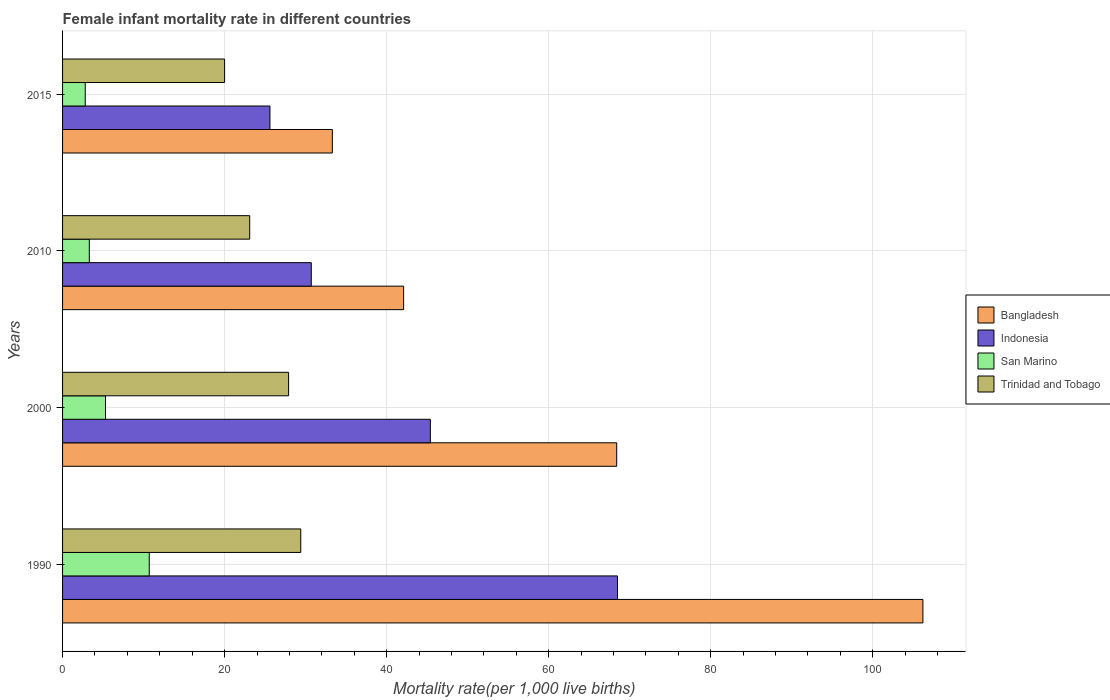How many different coloured bars are there?
Your answer should be very brief. 4. How many groups of bars are there?
Offer a very short reply. 4. Are the number of bars on each tick of the Y-axis equal?
Provide a short and direct response. Yes. In how many cases, is the number of bars for a given year not equal to the number of legend labels?
Keep it short and to the point. 0. Across all years, what is the maximum female infant mortality rate in Bangladesh?
Keep it short and to the point. 106.2. Across all years, what is the minimum female infant mortality rate in Trinidad and Tobago?
Offer a terse response. 20. In which year was the female infant mortality rate in San Marino minimum?
Make the answer very short. 2015. What is the total female infant mortality rate in Indonesia in the graph?
Offer a terse response. 170.2. What is the difference between the female infant mortality rate in Trinidad and Tobago in 2000 and that in 2010?
Your answer should be very brief. 4.8. What is the difference between the female infant mortality rate in San Marino in 2010 and the female infant mortality rate in Trinidad and Tobago in 2000?
Your answer should be compact. -24.6. What is the average female infant mortality rate in Indonesia per year?
Offer a terse response. 42.55. In the year 1990, what is the difference between the female infant mortality rate in Bangladesh and female infant mortality rate in San Marino?
Offer a terse response. 95.5. What is the ratio of the female infant mortality rate in Trinidad and Tobago in 2000 to that in 2010?
Your response must be concise. 1.21. Is the female infant mortality rate in San Marino in 2000 less than that in 2015?
Offer a terse response. No. Is the difference between the female infant mortality rate in Bangladesh in 2000 and 2015 greater than the difference between the female infant mortality rate in San Marino in 2000 and 2015?
Give a very brief answer. Yes. What is the difference between the highest and the second highest female infant mortality rate in Trinidad and Tobago?
Provide a short and direct response. 1.5. What is the difference between the highest and the lowest female infant mortality rate in Trinidad and Tobago?
Provide a succinct answer. 9.4. In how many years, is the female infant mortality rate in Indonesia greater than the average female infant mortality rate in Indonesia taken over all years?
Make the answer very short. 2. What does the 1st bar from the top in 1990 represents?
Give a very brief answer. Trinidad and Tobago. Is it the case that in every year, the sum of the female infant mortality rate in Bangladesh and female infant mortality rate in Indonesia is greater than the female infant mortality rate in San Marino?
Ensure brevity in your answer.  Yes. Are all the bars in the graph horizontal?
Your answer should be compact. Yes. How many years are there in the graph?
Your response must be concise. 4. What is the difference between two consecutive major ticks on the X-axis?
Make the answer very short. 20. Are the values on the major ticks of X-axis written in scientific E-notation?
Ensure brevity in your answer.  No. Does the graph contain grids?
Offer a terse response. Yes. How many legend labels are there?
Your response must be concise. 4. What is the title of the graph?
Ensure brevity in your answer.  Female infant mortality rate in different countries. What is the label or title of the X-axis?
Provide a short and direct response. Mortality rate(per 1,0 live births). What is the label or title of the Y-axis?
Give a very brief answer. Years. What is the Mortality rate(per 1,000 live births) of Bangladesh in 1990?
Offer a terse response. 106.2. What is the Mortality rate(per 1,000 live births) in Indonesia in 1990?
Offer a terse response. 68.5. What is the Mortality rate(per 1,000 live births) of Trinidad and Tobago in 1990?
Make the answer very short. 29.4. What is the Mortality rate(per 1,000 live births) in Bangladesh in 2000?
Your response must be concise. 68.4. What is the Mortality rate(per 1,000 live births) of Indonesia in 2000?
Your response must be concise. 45.4. What is the Mortality rate(per 1,000 live births) in San Marino in 2000?
Provide a succinct answer. 5.3. What is the Mortality rate(per 1,000 live births) of Trinidad and Tobago in 2000?
Provide a succinct answer. 27.9. What is the Mortality rate(per 1,000 live births) of Bangladesh in 2010?
Offer a terse response. 42.1. What is the Mortality rate(per 1,000 live births) of Indonesia in 2010?
Provide a short and direct response. 30.7. What is the Mortality rate(per 1,000 live births) in Trinidad and Tobago in 2010?
Your response must be concise. 23.1. What is the Mortality rate(per 1,000 live births) in Bangladesh in 2015?
Offer a very short reply. 33.3. What is the Mortality rate(per 1,000 live births) of Indonesia in 2015?
Keep it short and to the point. 25.6. Across all years, what is the maximum Mortality rate(per 1,000 live births) of Bangladesh?
Give a very brief answer. 106.2. Across all years, what is the maximum Mortality rate(per 1,000 live births) in Indonesia?
Your answer should be very brief. 68.5. Across all years, what is the maximum Mortality rate(per 1,000 live births) of Trinidad and Tobago?
Keep it short and to the point. 29.4. Across all years, what is the minimum Mortality rate(per 1,000 live births) in Bangladesh?
Your answer should be very brief. 33.3. Across all years, what is the minimum Mortality rate(per 1,000 live births) of Indonesia?
Give a very brief answer. 25.6. What is the total Mortality rate(per 1,000 live births) in Bangladesh in the graph?
Your answer should be compact. 250. What is the total Mortality rate(per 1,000 live births) in Indonesia in the graph?
Your response must be concise. 170.2. What is the total Mortality rate(per 1,000 live births) of San Marino in the graph?
Provide a succinct answer. 22.1. What is the total Mortality rate(per 1,000 live births) in Trinidad and Tobago in the graph?
Provide a short and direct response. 100.4. What is the difference between the Mortality rate(per 1,000 live births) of Bangladesh in 1990 and that in 2000?
Provide a succinct answer. 37.8. What is the difference between the Mortality rate(per 1,000 live births) of Indonesia in 1990 and that in 2000?
Offer a very short reply. 23.1. What is the difference between the Mortality rate(per 1,000 live births) in San Marino in 1990 and that in 2000?
Offer a terse response. 5.4. What is the difference between the Mortality rate(per 1,000 live births) in Trinidad and Tobago in 1990 and that in 2000?
Provide a short and direct response. 1.5. What is the difference between the Mortality rate(per 1,000 live births) of Bangladesh in 1990 and that in 2010?
Offer a very short reply. 64.1. What is the difference between the Mortality rate(per 1,000 live births) of Indonesia in 1990 and that in 2010?
Offer a very short reply. 37.8. What is the difference between the Mortality rate(per 1,000 live births) of Bangladesh in 1990 and that in 2015?
Your answer should be compact. 72.9. What is the difference between the Mortality rate(per 1,000 live births) in Indonesia in 1990 and that in 2015?
Offer a terse response. 42.9. What is the difference between the Mortality rate(per 1,000 live births) in Bangladesh in 2000 and that in 2010?
Offer a terse response. 26.3. What is the difference between the Mortality rate(per 1,000 live births) of Indonesia in 2000 and that in 2010?
Your answer should be compact. 14.7. What is the difference between the Mortality rate(per 1,000 live births) of San Marino in 2000 and that in 2010?
Offer a very short reply. 2. What is the difference between the Mortality rate(per 1,000 live births) of Bangladesh in 2000 and that in 2015?
Your answer should be very brief. 35.1. What is the difference between the Mortality rate(per 1,000 live births) in Indonesia in 2000 and that in 2015?
Provide a succinct answer. 19.8. What is the difference between the Mortality rate(per 1,000 live births) of Trinidad and Tobago in 2000 and that in 2015?
Ensure brevity in your answer.  7.9. What is the difference between the Mortality rate(per 1,000 live births) in Bangladesh in 2010 and that in 2015?
Give a very brief answer. 8.8. What is the difference between the Mortality rate(per 1,000 live births) in Indonesia in 2010 and that in 2015?
Give a very brief answer. 5.1. What is the difference between the Mortality rate(per 1,000 live births) of Bangladesh in 1990 and the Mortality rate(per 1,000 live births) of Indonesia in 2000?
Ensure brevity in your answer.  60.8. What is the difference between the Mortality rate(per 1,000 live births) of Bangladesh in 1990 and the Mortality rate(per 1,000 live births) of San Marino in 2000?
Ensure brevity in your answer.  100.9. What is the difference between the Mortality rate(per 1,000 live births) of Bangladesh in 1990 and the Mortality rate(per 1,000 live births) of Trinidad and Tobago in 2000?
Ensure brevity in your answer.  78.3. What is the difference between the Mortality rate(per 1,000 live births) of Indonesia in 1990 and the Mortality rate(per 1,000 live births) of San Marino in 2000?
Your answer should be very brief. 63.2. What is the difference between the Mortality rate(per 1,000 live births) in Indonesia in 1990 and the Mortality rate(per 1,000 live births) in Trinidad and Tobago in 2000?
Your answer should be very brief. 40.6. What is the difference between the Mortality rate(per 1,000 live births) in San Marino in 1990 and the Mortality rate(per 1,000 live births) in Trinidad and Tobago in 2000?
Make the answer very short. -17.2. What is the difference between the Mortality rate(per 1,000 live births) in Bangladesh in 1990 and the Mortality rate(per 1,000 live births) in Indonesia in 2010?
Provide a short and direct response. 75.5. What is the difference between the Mortality rate(per 1,000 live births) in Bangladesh in 1990 and the Mortality rate(per 1,000 live births) in San Marino in 2010?
Keep it short and to the point. 102.9. What is the difference between the Mortality rate(per 1,000 live births) of Bangladesh in 1990 and the Mortality rate(per 1,000 live births) of Trinidad and Tobago in 2010?
Make the answer very short. 83.1. What is the difference between the Mortality rate(per 1,000 live births) of Indonesia in 1990 and the Mortality rate(per 1,000 live births) of San Marino in 2010?
Ensure brevity in your answer.  65.2. What is the difference between the Mortality rate(per 1,000 live births) of Indonesia in 1990 and the Mortality rate(per 1,000 live births) of Trinidad and Tobago in 2010?
Ensure brevity in your answer.  45.4. What is the difference between the Mortality rate(per 1,000 live births) in Bangladesh in 1990 and the Mortality rate(per 1,000 live births) in Indonesia in 2015?
Offer a very short reply. 80.6. What is the difference between the Mortality rate(per 1,000 live births) of Bangladesh in 1990 and the Mortality rate(per 1,000 live births) of San Marino in 2015?
Your response must be concise. 103.4. What is the difference between the Mortality rate(per 1,000 live births) of Bangladesh in 1990 and the Mortality rate(per 1,000 live births) of Trinidad and Tobago in 2015?
Your answer should be very brief. 86.2. What is the difference between the Mortality rate(per 1,000 live births) of Indonesia in 1990 and the Mortality rate(per 1,000 live births) of San Marino in 2015?
Your answer should be very brief. 65.7. What is the difference between the Mortality rate(per 1,000 live births) in Indonesia in 1990 and the Mortality rate(per 1,000 live births) in Trinidad and Tobago in 2015?
Give a very brief answer. 48.5. What is the difference between the Mortality rate(per 1,000 live births) in Bangladesh in 2000 and the Mortality rate(per 1,000 live births) in Indonesia in 2010?
Your answer should be compact. 37.7. What is the difference between the Mortality rate(per 1,000 live births) in Bangladesh in 2000 and the Mortality rate(per 1,000 live births) in San Marino in 2010?
Keep it short and to the point. 65.1. What is the difference between the Mortality rate(per 1,000 live births) of Bangladesh in 2000 and the Mortality rate(per 1,000 live births) of Trinidad and Tobago in 2010?
Your response must be concise. 45.3. What is the difference between the Mortality rate(per 1,000 live births) in Indonesia in 2000 and the Mortality rate(per 1,000 live births) in San Marino in 2010?
Make the answer very short. 42.1. What is the difference between the Mortality rate(per 1,000 live births) in Indonesia in 2000 and the Mortality rate(per 1,000 live births) in Trinidad and Tobago in 2010?
Your answer should be compact. 22.3. What is the difference between the Mortality rate(per 1,000 live births) in San Marino in 2000 and the Mortality rate(per 1,000 live births) in Trinidad and Tobago in 2010?
Ensure brevity in your answer.  -17.8. What is the difference between the Mortality rate(per 1,000 live births) of Bangladesh in 2000 and the Mortality rate(per 1,000 live births) of Indonesia in 2015?
Provide a succinct answer. 42.8. What is the difference between the Mortality rate(per 1,000 live births) in Bangladesh in 2000 and the Mortality rate(per 1,000 live births) in San Marino in 2015?
Offer a very short reply. 65.6. What is the difference between the Mortality rate(per 1,000 live births) in Bangladesh in 2000 and the Mortality rate(per 1,000 live births) in Trinidad and Tobago in 2015?
Ensure brevity in your answer.  48.4. What is the difference between the Mortality rate(per 1,000 live births) in Indonesia in 2000 and the Mortality rate(per 1,000 live births) in San Marino in 2015?
Your response must be concise. 42.6. What is the difference between the Mortality rate(per 1,000 live births) in Indonesia in 2000 and the Mortality rate(per 1,000 live births) in Trinidad and Tobago in 2015?
Your response must be concise. 25.4. What is the difference between the Mortality rate(per 1,000 live births) in San Marino in 2000 and the Mortality rate(per 1,000 live births) in Trinidad and Tobago in 2015?
Your answer should be compact. -14.7. What is the difference between the Mortality rate(per 1,000 live births) in Bangladesh in 2010 and the Mortality rate(per 1,000 live births) in San Marino in 2015?
Offer a terse response. 39.3. What is the difference between the Mortality rate(per 1,000 live births) in Bangladesh in 2010 and the Mortality rate(per 1,000 live births) in Trinidad and Tobago in 2015?
Your answer should be compact. 22.1. What is the difference between the Mortality rate(per 1,000 live births) in Indonesia in 2010 and the Mortality rate(per 1,000 live births) in San Marino in 2015?
Your answer should be very brief. 27.9. What is the difference between the Mortality rate(per 1,000 live births) in San Marino in 2010 and the Mortality rate(per 1,000 live births) in Trinidad and Tobago in 2015?
Offer a very short reply. -16.7. What is the average Mortality rate(per 1,000 live births) in Bangladesh per year?
Ensure brevity in your answer.  62.5. What is the average Mortality rate(per 1,000 live births) in Indonesia per year?
Provide a short and direct response. 42.55. What is the average Mortality rate(per 1,000 live births) in San Marino per year?
Your response must be concise. 5.53. What is the average Mortality rate(per 1,000 live births) of Trinidad and Tobago per year?
Your response must be concise. 25.1. In the year 1990, what is the difference between the Mortality rate(per 1,000 live births) in Bangladesh and Mortality rate(per 1,000 live births) in Indonesia?
Provide a succinct answer. 37.7. In the year 1990, what is the difference between the Mortality rate(per 1,000 live births) in Bangladesh and Mortality rate(per 1,000 live births) in San Marino?
Make the answer very short. 95.5. In the year 1990, what is the difference between the Mortality rate(per 1,000 live births) in Bangladesh and Mortality rate(per 1,000 live births) in Trinidad and Tobago?
Give a very brief answer. 76.8. In the year 1990, what is the difference between the Mortality rate(per 1,000 live births) in Indonesia and Mortality rate(per 1,000 live births) in San Marino?
Ensure brevity in your answer.  57.8. In the year 1990, what is the difference between the Mortality rate(per 1,000 live births) of Indonesia and Mortality rate(per 1,000 live births) of Trinidad and Tobago?
Provide a succinct answer. 39.1. In the year 1990, what is the difference between the Mortality rate(per 1,000 live births) in San Marino and Mortality rate(per 1,000 live births) in Trinidad and Tobago?
Your response must be concise. -18.7. In the year 2000, what is the difference between the Mortality rate(per 1,000 live births) of Bangladesh and Mortality rate(per 1,000 live births) of San Marino?
Offer a terse response. 63.1. In the year 2000, what is the difference between the Mortality rate(per 1,000 live births) in Bangladesh and Mortality rate(per 1,000 live births) in Trinidad and Tobago?
Your answer should be very brief. 40.5. In the year 2000, what is the difference between the Mortality rate(per 1,000 live births) of Indonesia and Mortality rate(per 1,000 live births) of San Marino?
Offer a very short reply. 40.1. In the year 2000, what is the difference between the Mortality rate(per 1,000 live births) in San Marino and Mortality rate(per 1,000 live births) in Trinidad and Tobago?
Keep it short and to the point. -22.6. In the year 2010, what is the difference between the Mortality rate(per 1,000 live births) of Bangladesh and Mortality rate(per 1,000 live births) of Indonesia?
Ensure brevity in your answer.  11.4. In the year 2010, what is the difference between the Mortality rate(per 1,000 live births) in Bangladesh and Mortality rate(per 1,000 live births) in San Marino?
Give a very brief answer. 38.8. In the year 2010, what is the difference between the Mortality rate(per 1,000 live births) of Bangladesh and Mortality rate(per 1,000 live births) of Trinidad and Tobago?
Give a very brief answer. 19. In the year 2010, what is the difference between the Mortality rate(per 1,000 live births) of Indonesia and Mortality rate(per 1,000 live births) of San Marino?
Give a very brief answer. 27.4. In the year 2010, what is the difference between the Mortality rate(per 1,000 live births) in San Marino and Mortality rate(per 1,000 live births) in Trinidad and Tobago?
Your answer should be very brief. -19.8. In the year 2015, what is the difference between the Mortality rate(per 1,000 live births) of Bangladesh and Mortality rate(per 1,000 live births) of Indonesia?
Make the answer very short. 7.7. In the year 2015, what is the difference between the Mortality rate(per 1,000 live births) of Bangladesh and Mortality rate(per 1,000 live births) of San Marino?
Offer a very short reply. 30.5. In the year 2015, what is the difference between the Mortality rate(per 1,000 live births) in Bangladesh and Mortality rate(per 1,000 live births) in Trinidad and Tobago?
Your answer should be very brief. 13.3. In the year 2015, what is the difference between the Mortality rate(per 1,000 live births) in Indonesia and Mortality rate(per 1,000 live births) in San Marino?
Provide a short and direct response. 22.8. In the year 2015, what is the difference between the Mortality rate(per 1,000 live births) of San Marino and Mortality rate(per 1,000 live births) of Trinidad and Tobago?
Offer a terse response. -17.2. What is the ratio of the Mortality rate(per 1,000 live births) of Bangladesh in 1990 to that in 2000?
Your answer should be very brief. 1.55. What is the ratio of the Mortality rate(per 1,000 live births) of Indonesia in 1990 to that in 2000?
Provide a short and direct response. 1.51. What is the ratio of the Mortality rate(per 1,000 live births) in San Marino in 1990 to that in 2000?
Offer a terse response. 2.02. What is the ratio of the Mortality rate(per 1,000 live births) of Trinidad and Tobago in 1990 to that in 2000?
Give a very brief answer. 1.05. What is the ratio of the Mortality rate(per 1,000 live births) in Bangladesh in 1990 to that in 2010?
Provide a succinct answer. 2.52. What is the ratio of the Mortality rate(per 1,000 live births) in Indonesia in 1990 to that in 2010?
Your answer should be very brief. 2.23. What is the ratio of the Mortality rate(per 1,000 live births) of San Marino in 1990 to that in 2010?
Give a very brief answer. 3.24. What is the ratio of the Mortality rate(per 1,000 live births) in Trinidad and Tobago in 1990 to that in 2010?
Offer a terse response. 1.27. What is the ratio of the Mortality rate(per 1,000 live births) of Bangladesh in 1990 to that in 2015?
Provide a short and direct response. 3.19. What is the ratio of the Mortality rate(per 1,000 live births) in Indonesia in 1990 to that in 2015?
Ensure brevity in your answer.  2.68. What is the ratio of the Mortality rate(per 1,000 live births) in San Marino in 1990 to that in 2015?
Give a very brief answer. 3.82. What is the ratio of the Mortality rate(per 1,000 live births) in Trinidad and Tobago in 1990 to that in 2015?
Provide a short and direct response. 1.47. What is the ratio of the Mortality rate(per 1,000 live births) in Bangladesh in 2000 to that in 2010?
Your answer should be compact. 1.62. What is the ratio of the Mortality rate(per 1,000 live births) in Indonesia in 2000 to that in 2010?
Offer a very short reply. 1.48. What is the ratio of the Mortality rate(per 1,000 live births) in San Marino in 2000 to that in 2010?
Your answer should be very brief. 1.61. What is the ratio of the Mortality rate(per 1,000 live births) in Trinidad and Tobago in 2000 to that in 2010?
Provide a short and direct response. 1.21. What is the ratio of the Mortality rate(per 1,000 live births) of Bangladesh in 2000 to that in 2015?
Offer a very short reply. 2.05. What is the ratio of the Mortality rate(per 1,000 live births) of Indonesia in 2000 to that in 2015?
Give a very brief answer. 1.77. What is the ratio of the Mortality rate(per 1,000 live births) in San Marino in 2000 to that in 2015?
Provide a succinct answer. 1.89. What is the ratio of the Mortality rate(per 1,000 live births) in Trinidad and Tobago in 2000 to that in 2015?
Offer a very short reply. 1.4. What is the ratio of the Mortality rate(per 1,000 live births) in Bangladesh in 2010 to that in 2015?
Your response must be concise. 1.26. What is the ratio of the Mortality rate(per 1,000 live births) in Indonesia in 2010 to that in 2015?
Provide a short and direct response. 1.2. What is the ratio of the Mortality rate(per 1,000 live births) in San Marino in 2010 to that in 2015?
Offer a terse response. 1.18. What is the ratio of the Mortality rate(per 1,000 live births) of Trinidad and Tobago in 2010 to that in 2015?
Your answer should be very brief. 1.16. What is the difference between the highest and the second highest Mortality rate(per 1,000 live births) of Bangladesh?
Give a very brief answer. 37.8. What is the difference between the highest and the second highest Mortality rate(per 1,000 live births) in Indonesia?
Your answer should be compact. 23.1. What is the difference between the highest and the second highest Mortality rate(per 1,000 live births) of Trinidad and Tobago?
Make the answer very short. 1.5. What is the difference between the highest and the lowest Mortality rate(per 1,000 live births) in Bangladesh?
Make the answer very short. 72.9. What is the difference between the highest and the lowest Mortality rate(per 1,000 live births) in Indonesia?
Your answer should be very brief. 42.9. What is the difference between the highest and the lowest Mortality rate(per 1,000 live births) of San Marino?
Offer a terse response. 7.9. What is the difference between the highest and the lowest Mortality rate(per 1,000 live births) in Trinidad and Tobago?
Your response must be concise. 9.4. 